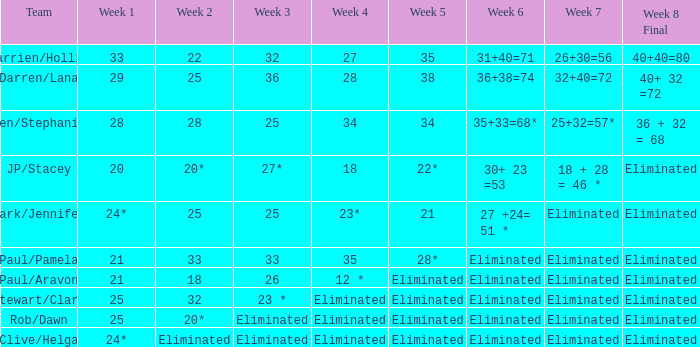Identify the week 3 with week 6 of 31+40=71 32.0. 